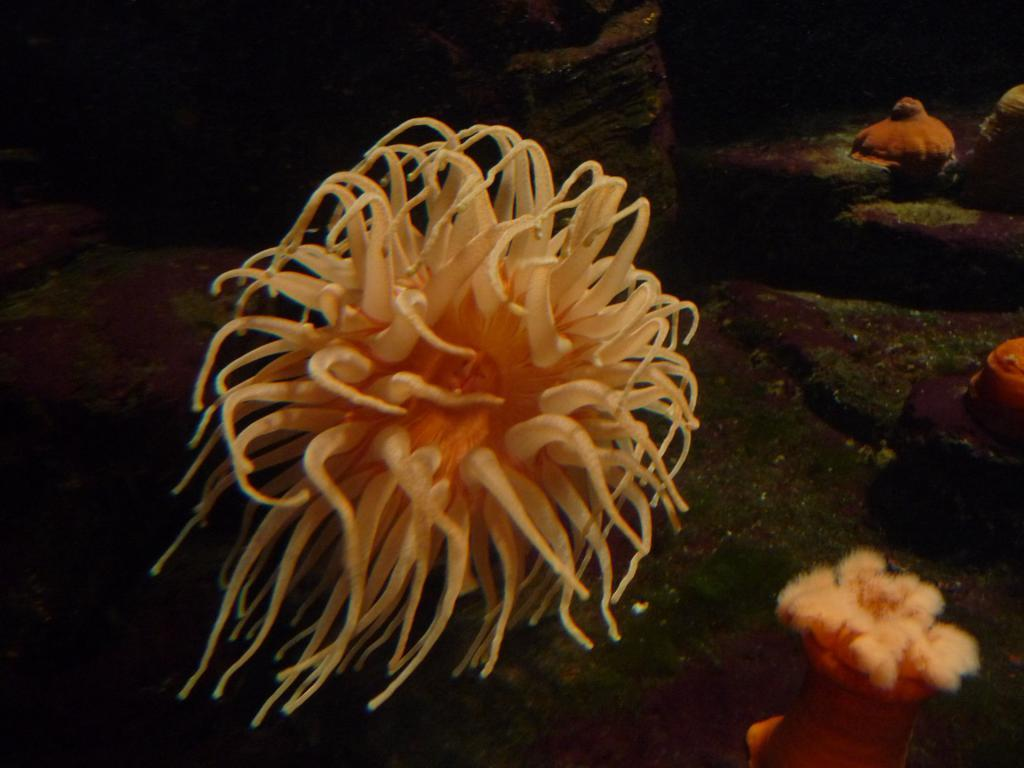What type of sea creatures are in the image? There are jellyfish in the image. What other objects can be seen in the image? There are stones in the image. Can you describe the background of the image? The background of the image is dark. What type of toothbrush is being used to draw on the stones in the image? There is no toothbrush or drawing activity present in the image. 